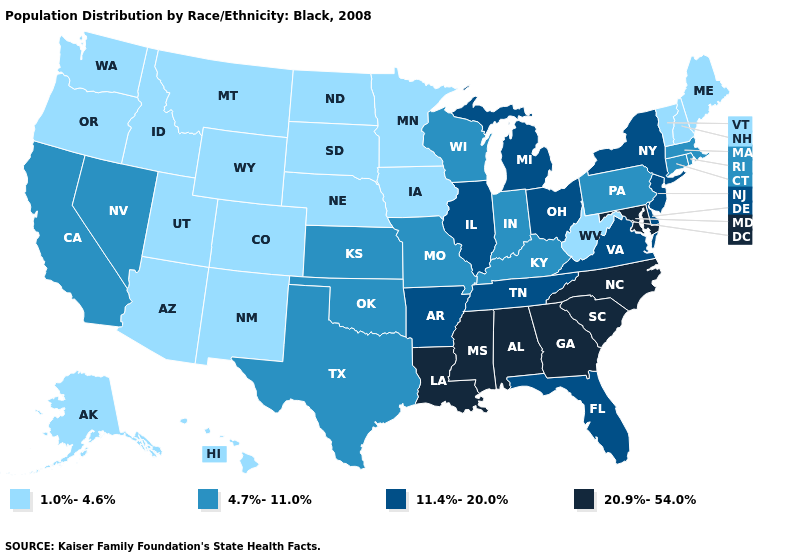What is the value of Massachusetts?
Keep it brief. 4.7%-11.0%. What is the value of Ohio?
Quick response, please. 11.4%-20.0%. Name the states that have a value in the range 20.9%-54.0%?
Be succinct. Alabama, Georgia, Louisiana, Maryland, Mississippi, North Carolina, South Carolina. What is the value of Alaska?
Concise answer only. 1.0%-4.6%. Name the states that have a value in the range 20.9%-54.0%?
Answer briefly. Alabama, Georgia, Louisiana, Maryland, Mississippi, North Carolina, South Carolina. Name the states that have a value in the range 20.9%-54.0%?
Be succinct. Alabama, Georgia, Louisiana, Maryland, Mississippi, North Carolina, South Carolina. Does Utah have the same value as Nebraska?
Short answer required. Yes. Name the states that have a value in the range 20.9%-54.0%?
Keep it brief. Alabama, Georgia, Louisiana, Maryland, Mississippi, North Carolina, South Carolina. Name the states that have a value in the range 11.4%-20.0%?
Give a very brief answer. Arkansas, Delaware, Florida, Illinois, Michigan, New Jersey, New York, Ohio, Tennessee, Virginia. What is the value of Colorado?
Write a very short answer. 1.0%-4.6%. What is the lowest value in the USA?
Keep it brief. 1.0%-4.6%. Does South Carolina have the same value as Virginia?
Short answer required. No. What is the value of Nebraska?
Quick response, please. 1.0%-4.6%. What is the lowest value in the USA?
Concise answer only. 1.0%-4.6%. What is the highest value in states that border Florida?
Answer briefly. 20.9%-54.0%. 